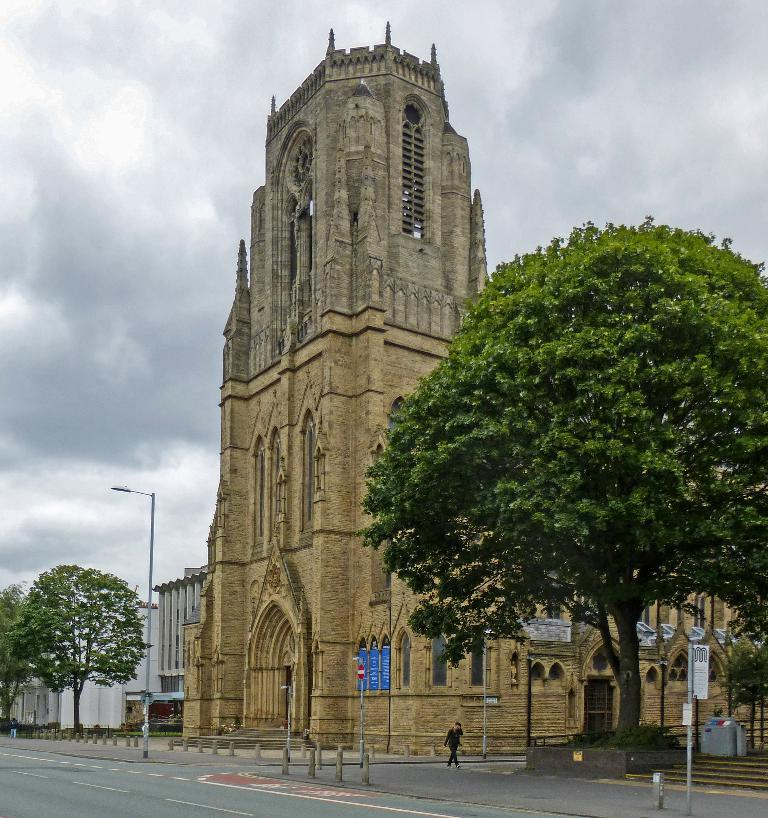What type of natural elements can be seen in the image? There are trees in the image. What type of man-made structures are visible in the image? There are buildings in the image. What other objects can be seen in the image? There are poles in the image. Who is present in the image? There is a man in the middle of the image. What can be seen in the background of the image? There are clouds in the background of the image. What is the price of the wrench in the image? There is no wrench present in the image, so it is not possible to determine its price. 